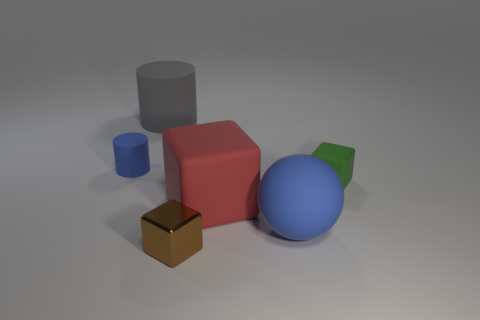The thing that is the same color as the ball is what shape?
Make the answer very short. Cylinder. Is there any other thing that is the same color as the large ball?
Provide a succinct answer. Yes. How many shiny objects are either big red cubes or blue spheres?
Keep it short and to the point. 0. Does the sphere have the same color as the small matte cylinder?
Make the answer very short. Yes. Are there more big things that are on the left side of the big red thing than big gray cubes?
Ensure brevity in your answer.  Yes. What number of other things are there of the same material as the small cylinder
Make the answer very short. 4. What number of tiny objects are either green cubes or brown metal blocks?
Your answer should be compact. 2. Is the material of the ball the same as the small brown cube?
Your response must be concise. No. How many gray cylinders are in front of the big thing that is behind the tiny blue rubber object?
Offer a terse response. 0. Is there a green thing of the same shape as the red thing?
Ensure brevity in your answer.  Yes. 